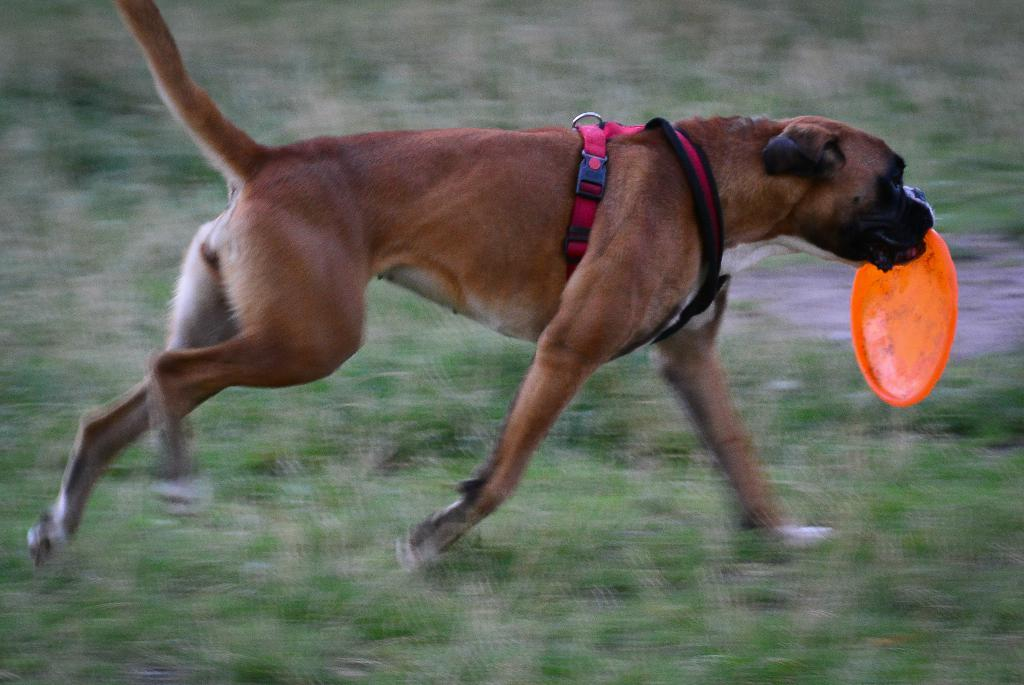What animal can be seen in the image? There is a dog in the image. What is the dog doing in the image? The dog is walking on the grass. What object is the dog holding in its mouth? The dog is holding a Frisbee in its mouth. What type of pickle is the dog eating in the image? There is no pickle present in the image; the dog is holding a Frisbee in its mouth. How many boys are visible in the image? There are no boys visible in the image; the main subject is a dog. 